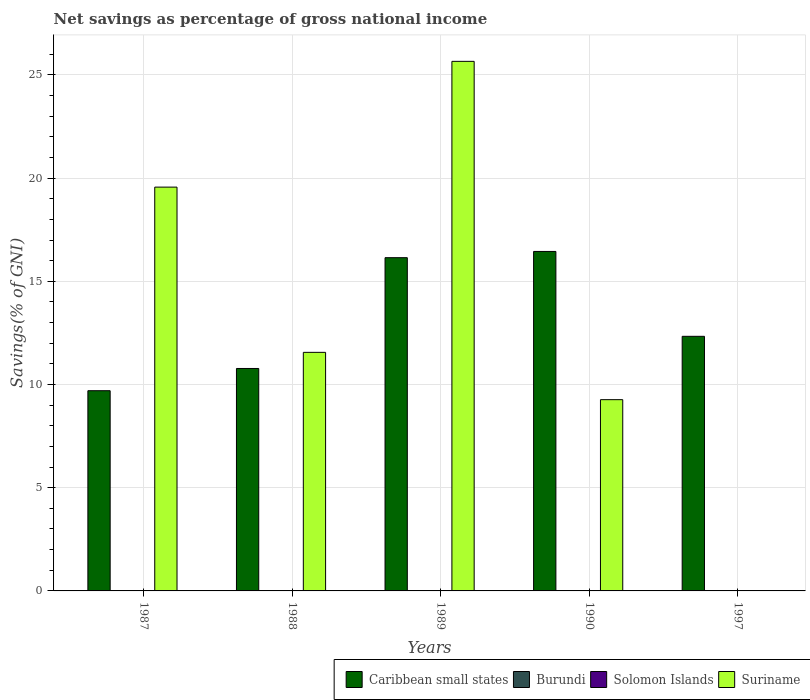How many different coloured bars are there?
Offer a very short reply. 2. Are the number of bars on each tick of the X-axis equal?
Your answer should be very brief. No. How many bars are there on the 4th tick from the right?
Provide a short and direct response. 2. In how many cases, is the number of bars for a given year not equal to the number of legend labels?
Your answer should be very brief. 5. What is the total savings in Solomon Islands in 1990?
Your answer should be compact. 0. Across all years, what is the maximum total savings in Suriname?
Offer a terse response. 25.66. Across all years, what is the minimum total savings in Solomon Islands?
Ensure brevity in your answer.  0. What is the total total savings in Caribbean small states in the graph?
Ensure brevity in your answer.  65.4. What is the difference between the total savings in Suriname in 1988 and that in 1990?
Offer a very short reply. 2.29. What is the difference between the total savings in Caribbean small states in 1989 and the total savings in Suriname in 1990?
Provide a short and direct response. 6.88. What is the average total savings in Suriname per year?
Ensure brevity in your answer.  13.21. In the year 1987, what is the difference between the total savings in Suriname and total savings in Caribbean small states?
Ensure brevity in your answer.  9.86. In how many years, is the total savings in Suriname greater than 13 %?
Provide a succinct answer. 2. What is the ratio of the total savings in Suriname in 1988 to that in 1989?
Give a very brief answer. 0.45. Is the total savings in Caribbean small states in 1988 less than that in 1989?
Give a very brief answer. Yes. What is the difference between the highest and the second highest total savings in Caribbean small states?
Make the answer very short. 0.3. What is the difference between the highest and the lowest total savings in Caribbean small states?
Provide a succinct answer. 6.75. In how many years, is the total savings in Solomon Islands greater than the average total savings in Solomon Islands taken over all years?
Offer a very short reply. 0. Is it the case that in every year, the sum of the total savings in Burundi and total savings in Caribbean small states is greater than the sum of total savings in Suriname and total savings in Solomon Islands?
Offer a terse response. No. Is it the case that in every year, the sum of the total savings in Suriname and total savings in Caribbean small states is greater than the total savings in Burundi?
Offer a terse response. Yes. How many bars are there?
Offer a terse response. 9. Are all the bars in the graph horizontal?
Ensure brevity in your answer.  No. Are the values on the major ticks of Y-axis written in scientific E-notation?
Provide a succinct answer. No. Does the graph contain grids?
Provide a succinct answer. Yes. Where does the legend appear in the graph?
Offer a very short reply. Bottom right. How are the legend labels stacked?
Ensure brevity in your answer.  Horizontal. What is the title of the graph?
Make the answer very short. Net savings as percentage of gross national income. Does "Maldives" appear as one of the legend labels in the graph?
Provide a succinct answer. No. What is the label or title of the Y-axis?
Give a very brief answer. Savings(% of GNI). What is the Savings(% of GNI) of Caribbean small states in 1987?
Keep it short and to the point. 9.7. What is the Savings(% of GNI) of Solomon Islands in 1987?
Offer a terse response. 0. What is the Savings(% of GNI) of Suriname in 1987?
Keep it short and to the point. 19.56. What is the Savings(% of GNI) in Caribbean small states in 1988?
Ensure brevity in your answer.  10.78. What is the Savings(% of GNI) in Burundi in 1988?
Your answer should be very brief. 0. What is the Savings(% of GNI) in Solomon Islands in 1988?
Your answer should be compact. 0. What is the Savings(% of GNI) of Suriname in 1988?
Give a very brief answer. 11.56. What is the Savings(% of GNI) in Caribbean small states in 1989?
Your answer should be very brief. 16.14. What is the Savings(% of GNI) of Suriname in 1989?
Provide a succinct answer. 25.66. What is the Savings(% of GNI) of Caribbean small states in 1990?
Your response must be concise. 16.45. What is the Savings(% of GNI) in Burundi in 1990?
Provide a short and direct response. 0. What is the Savings(% of GNI) of Suriname in 1990?
Make the answer very short. 9.27. What is the Savings(% of GNI) of Caribbean small states in 1997?
Your response must be concise. 12.33. Across all years, what is the maximum Savings(% of GNI) of Caribbean small states?
Offer a terse response. 16.45. Across all years, what is the maximum Savings(% of GNI) in Suriname?
Keep it short and to the point. 25.66. Across all years, what is the minimum Savings(% of GNI) in Caribbean small states?
Your answer should be compact. 9.7. What is the total Savings(% of GNI) in Caribbean small states in the graph?
Provide a short and direct response. 65.4. What is the total Savings(% of GNI) of Burundi in the graph?
Your answer should be compact. 0. What is the total Savings(% of GNI) in Suriname in the graph?
Your answer should be compact. 66.04. What is the difference between the Savings(% of GNI) in Caribbean small states in 1987 and that in 1988?
Offer a terse response. -1.08. What is the difference between the Savings(% of GNI) of Suriname in 1987 and that in 1988?
Ensure brevity in your answer.  8. What is the difference between the Savings(% of GNI) in Caribbean small states in 1987 and that in 1989?
Give a very brief answer. -6.44. What is the difference between the Savings(% of GNI) of Suriname in 1987 and that in 1989?
Offer a very short reply. -6.09. What is the difference between the Savings(% of GNI) of Caribbean small states in 1987 and that in 1990?
Your response must be concise. -6.75. What is the difference between the Savings(% of GNI) in Suriname in 1987 and that in 1990?
Your answer should be compact. 10.3. What is the difference between the Savings(% of GNI) of Caribbean small states in 1987 and that in 1997?
Your answer should be very brief. -2.64. What is the difference between the Savings(% of GNI) in Caribbean small states in 1988 and that in 1989?
Give a very brief answer. -5.37. What is the difference between the Savings(% of GNI) of Suriname in 1988 and that in 1989?
Keep it short and to the point. -14.1. What is the difference between the Savings(% of GNI) of Caribbean small states in 1988 and that in 1990?
Offer a very short reply. -5.67. What is the difference between the Savings(% of GNI) in Suriname in 1988 and that in 1990?
Make the answer very short. 2.29. What is the difference between the Savings(% of GNI) of Caribbean small states in 1988 and that in 1997?
Offer a terse response. -1.56. What is the difference between the Savings(% of GNI) of Caribbean small states in 1989 and that in 1990?
Provide a short and direct response. -0.3. What is the difference between the Savings(% of GNI) of Suriname in 1989 and that in 1990?
Your answer should be compact. 16.39. What is the difference between the Savings(% of GNI) in Caribbean small states in 1989 and that in 1997?
Your answer should be compact. 3.81. What is the difference between the Savings(% of GNI) of Caribbean small states in 1990 and that in 1997?
Ensure brevity in your answer.  4.11. What is the difference between the Savings(% of GNI) of Caribbean small states in 1987 and the Savings(% of GNI) of Suriname in 1988?
Provide a succinct answer. -1.86. What is the difference between the Savings(% of GNI) in Caribbean small states in 1987 and the Savings(% of GNI) in Suriname in 1989?
Keep it short and to the point. -15.96. What is the difference between the Savings(% of GNI) of Caribbean small states in 1987 and the Savings(% of GNI) of Suriname in 1990?
Make the answer very short. 0.43. What is the difference between the Savings(% of GNI) of Caribbean small states in 1988 and the Savings(% of GNI) of Suriname in 1989?
Your response must be concise. -14.88. What is the difference between the Savings(% of GNI) in Caribbean small states in 1988 and the Savings(% of GNI) in Suriname in 1990?
Make the answer very short. 1.51. What is the difference between the Savings(% of GNI) in Caribbean small states in 1989 and the Savings(% of GNI) in Suriname in 1990?
Offer a terse response. 6.88. What is the average Savings(% of GNI) in Caribbean small states per year?
Offer a terse response. 13.08. What is the average Savings(% of GNI) of Suriname per year?
Make the answer very short. 13.21. In the year 1987, what is the difference between the Savings(% of GNI) in Caribbean small states and Savings(% of GNI) in Suriname?
Your answer should be compact. -9.86. In the year 1988, what is the difference between the Savings(% of GNI) in Caribbean small states and Savings(% of GNI) in Suriname?
Offer a terse response. -0.78. In the year 1989, what is the difference between the Savings(% of GNI) of Caribbean small states and Savings(% of GNI) of Suriname?
Provide a short and direct response. -9.51. In the year 1990, what is the difference between the Savings(% of GNI) in Caribbean small states and Savings(% of GNI) in Suriname?
Your response must be concise. 7.18. What is the ratio of the Savings(% of GNI) in Caribbean small states in 1987 to that in 1988?
Offer a very short reply. 0.9. What is the ratio of the Savings(% of GNI) of Suriname in 1987 to that in 1988?
Provide a short and direct response. 1.69. What is the ratio of the Savings(% of GNI) of Caribbean small states in 1987 to that in 1989?
Ensure brevity in your answer.  0.6. What is the ratio of the Savings(% of GNI) of Suriname in 1987 to that in 1989?
Offer a very short reply. 0.76. What is the ratio of the Savings(% of GNI) in Caribbean small states in 1987 to that in 1990?
Provide a short and direct response. 0.59. What is the ratio of the Savings(% of GNI) of Suriname in 1987 to that in 1990?
Offer a very short reply. 2.11. What is the ratio of the Savings(% of GNI) in Caribbean small states in 1987 to that in 1997?
Your response must be concise. 0.79. What is the ratio of the Savings(% of GNI) of Caribbean small states in 1988 to that in 1989?
Offer a terse response. 0.67. What is the ratio of the Savings(% of GNI) of Suriname in 1988 to that in 1989?
Your answer should be very brief. 0.45. What is the ratio of the Savings(% of GNI) of Caribbean small states in 1988 to that in 1990?
Your answer should be very brief. 0.66. What is the ratio of the Savings(% of GNI) in Suriname in 1988 to that in 1990?
Offer a terse response. 1.25. What is the ratio of the Savings(% of GNI) in Caribbean small states in 1988 to that in 1997?
Offer a terse response. 0.87. What is the ratio of the Savings(% of GNI) of Caribbean small states in 1989 to that in 1990?
Make the answer very short. 0.98. What is the ratio of the Savings(% of GNI) in Suriname in 1989 to that in 1990?
Your response must be concise. 2.77. What is the ratio of the Savings(% of GNI) in Caribbean small states in 1989 to that in 1997?
Provide a short and direct response. 1.31. What is the difference between the highest and the second highest Savings(% of GNI) of Caribbean small states?
Offer a very short reply. 0.3. What is the difference between the highest and the second highest Savings(% of GNI) in Suriname?
Your answer should be compact. 6.09. What is the difference between the highest and the lowest Savings(% of GNI) of Caribbean small states?
Offer a terse response. 6.75. What is the difference between the highest and the lowest Savings(% of GNI) of Suriname?
Keep it short and to the point. 25.66. 